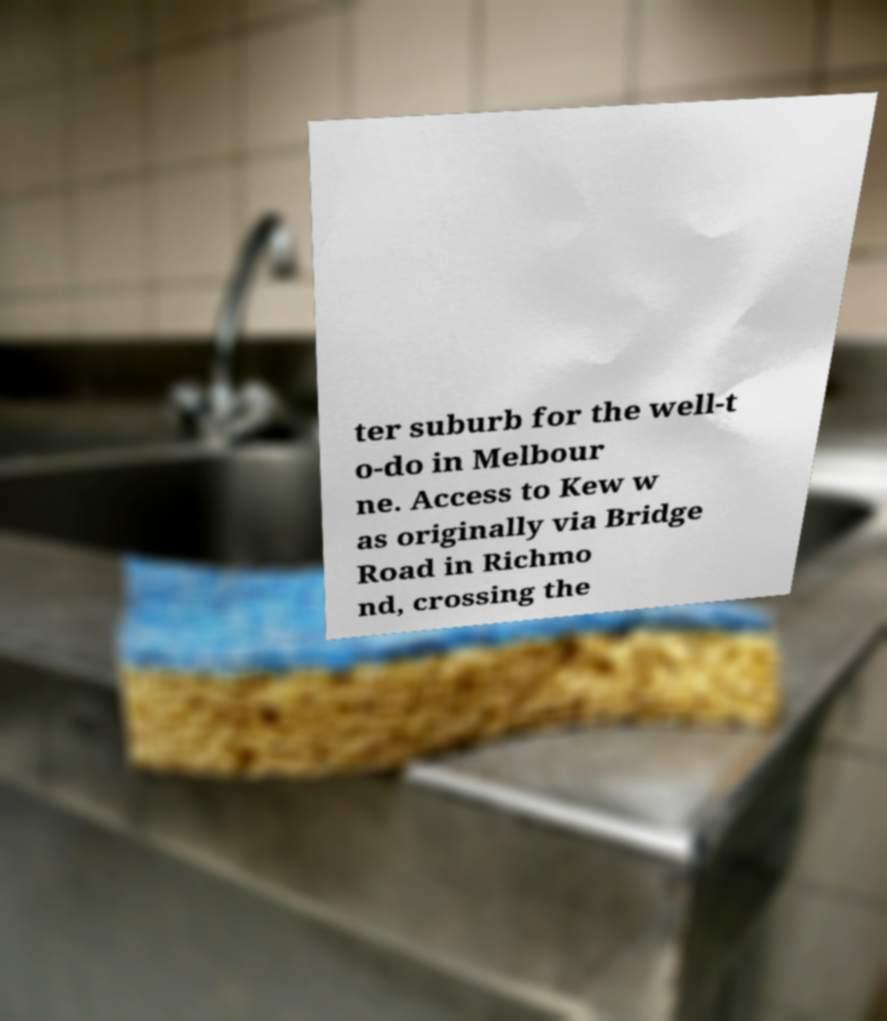What messages or text are displayed in this image? I need them in a readable, typed format. ter suburb for the well-t o-do in Melbour ne. Access to Kew w as originally via Bridge Road in Richmo nd, crossing the 